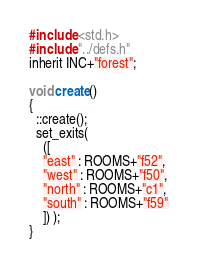Convert code to text. <code><loc_0><loc_0><loc_500><loc_500><_C_>#include <std.h>
#include "../defs.h"
inherit INC+"forest";

void create()
{
  ::create();
  set_exits(
    ([
    "east" : ROOMS+"f52",
    "west" : ROOMS+"f50",
    "north" : ROOMS+"c1",
    "south" : ROOMS+"f59"
    ]) );
}</code> 